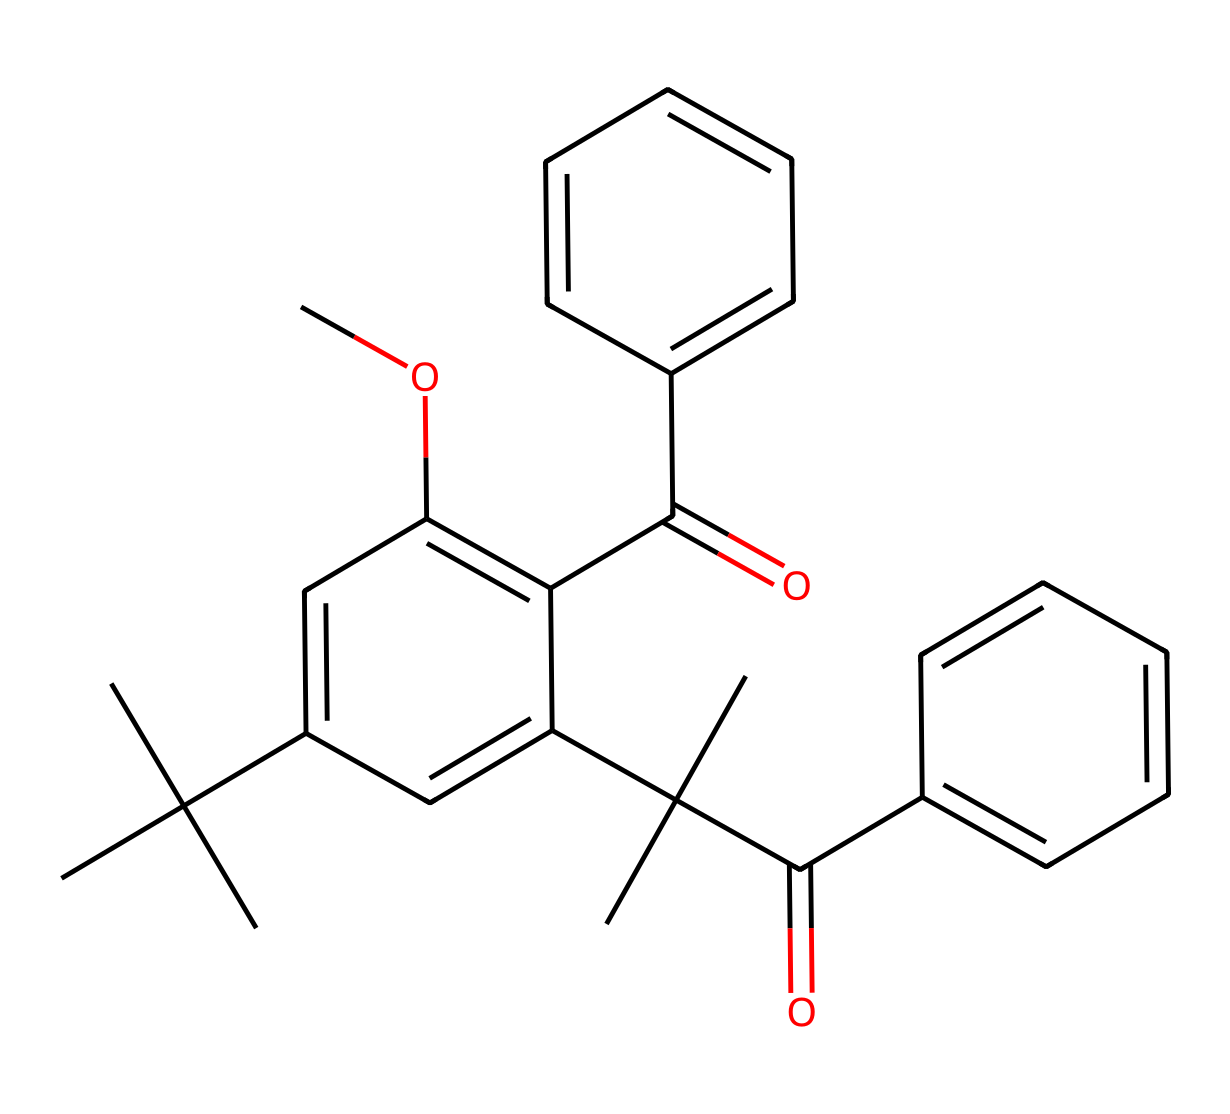What is the molecular formula of this compound? By analyzing the structure and counting the number of each type of atom, we find there are 24 carbon (C), 34 hydrogen (H), and 4 oxygen (O) atoms in the molecule. Therefore, the molecular formula can be deduced as C24H34O4.
Answer: C24H34O4 How many rings are present in the structure? Observing the chemical structure, we can identify two distinct aromatic rings based on the cyclic arrangement of carbon atoms. Counting these gives us a total of two rings.
Answer: 2 What type of chemical is this compound? The presence of multiple aromatic rings and carbon chains suggests that this compound is a type of polycyclic aromatic compound, commonly found in sunscreens as UV blockers or stabilizers.
Answer: polycyclic aromatic compound Is this chemical likely to be hydrophilic or hydrophobic? The predominantly carbon and hydrogen composition, along with the presence of only a few oxygen atoms, indicates that this compound is hydrophobic. This is typical for many sunscreen components, which need to repel water and provide a protective barrier.
Answer: hydrophobic What functional groups are present in the structure? By closely examining the chemical structure, we see that it possesses carbonyl groups (C=O) and an ether linkage (C-O-C), which are characteristic of its chemical class. Therefore, the functional groups identified are ketones and ethers.
Answer: ketones, ethers 